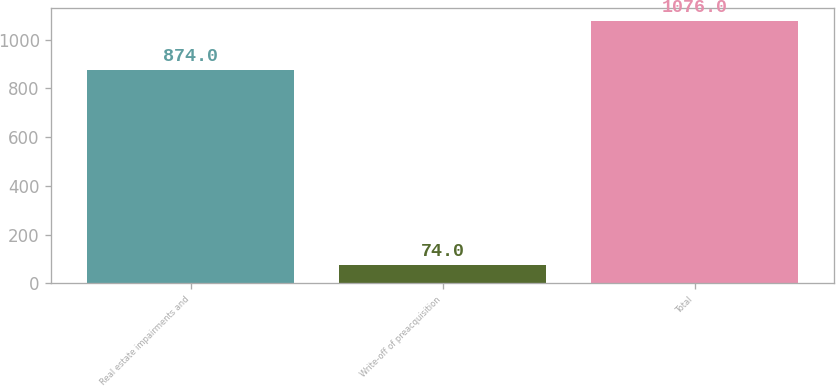<chart> <loc_0><loc_0><loc_500><loc_500><bar_chart><fcel>Real estate impairments and<fcel>Write-off of preacquisition<fcel>Total<nl><fcel>874<fcel>74<fcel>1076<nl></chart> 